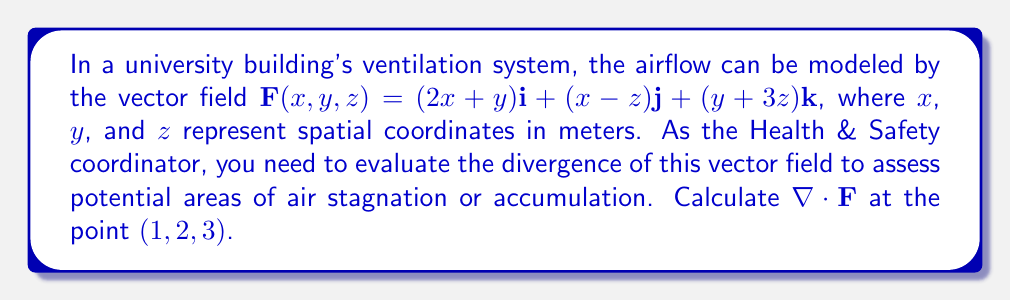Show me your answer to this math problem. To evaluate the divergence of the vector field, we'll follow these steps:

1) The divergence of a vector field $\mathbf{F}(x,y,z) = P\mathbf{i} + Q\mathbf{j} + R\mathbf{k}$ is given by:

   $$\nabla \cdot \mathbf{F} = \frac{\partial P}{\partial x} + \frac{\partial Q}{\partial y} + \frac{\partial R}{\partial z}$$

2) In our case:
   $P = 2x+y$
   $Q = x-z$
   $R = y+3z$

3) Let's calculate each partial derivative:

   $$\frac{\partial P}{\partial x} = \frac{\partial}{\partial x}(2x+y) = 2$$
   
   $$\frac{\partial Q}{\partial y} = \frac{\partial}{\partial y}(x-z) = 0$$
   
   $$\frac{\partial R}{\partial z} = \frac{\partial}{\partial z}(y+3z) = 3$$

4) Now, we can sum these partial derivatives:

   $$\nabla \cdot \mathbf{F} = 2 + 0 + 3 = 5$$

5) This result is constant and doesn't depend on $x$, $y$, or $z$, so it's the same at all points, including $(1,2,3)$.

The positive divergence indicates that there's a net outflow of air from each point in the ventilation system, which is good for air circulation and preventing stagnation.
Answer: $5$ 